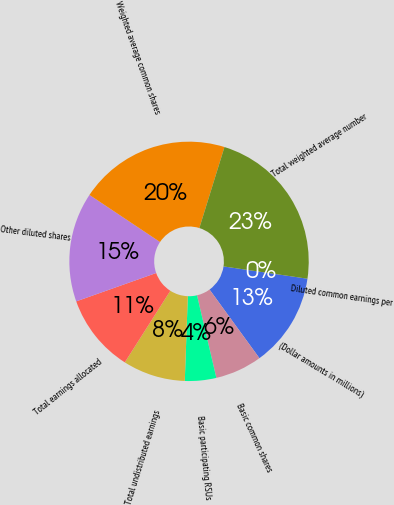Convert chart to OTSL. <chart><loc_0><loc_0><loc_500><loc_500><pie_chart><fcel>(Dollar amounts in millions)<fcel>Basic common shares<fcel>Basic participating RSUs<fcel>Total undistributed earnings<fcel>Total earnings allocated<fcel>Other diluted shares<fcel>Weighted average common shares<fcel>Total weighted average number<fcel>Diluted common earnings per<nl><fcel>12.68%<fcel>6.34%<fcel>4.23%<fcel>8.45%<fcel>10.56%<fcel>14.79%<fcel>20.42%<fcel>22.53%<fcel>0.0%<nl></chart> 